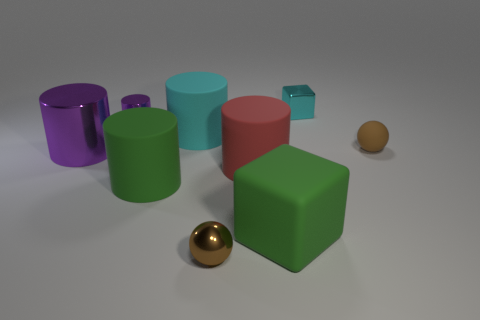Subtract all tiny cylinders. How many cylinders are left? 4 Subtract all purple cylinders. How many cylinders are left? 3 Add 1 brown metallic objects. How many objects exist? 10 Subtract 1 blocks. How many blocks are left? 1 Subtract all red cylinders. Subtract all blue cubes. How many cylinders are left? 4 Subtract all red cubes. How many red cylinders are left? 1 Subtract all small cyan shiny cylinders. Subtract all tiny balls. How many objects are left? 7 Add 2 purple metallic cylinders. How many purple metallic cylinders are left? 4 Add 9 tiny brown rubber objects. How many tiny brown rubber objects exist? 10 Subtract 0 purple balls. How many objects are left? 9 